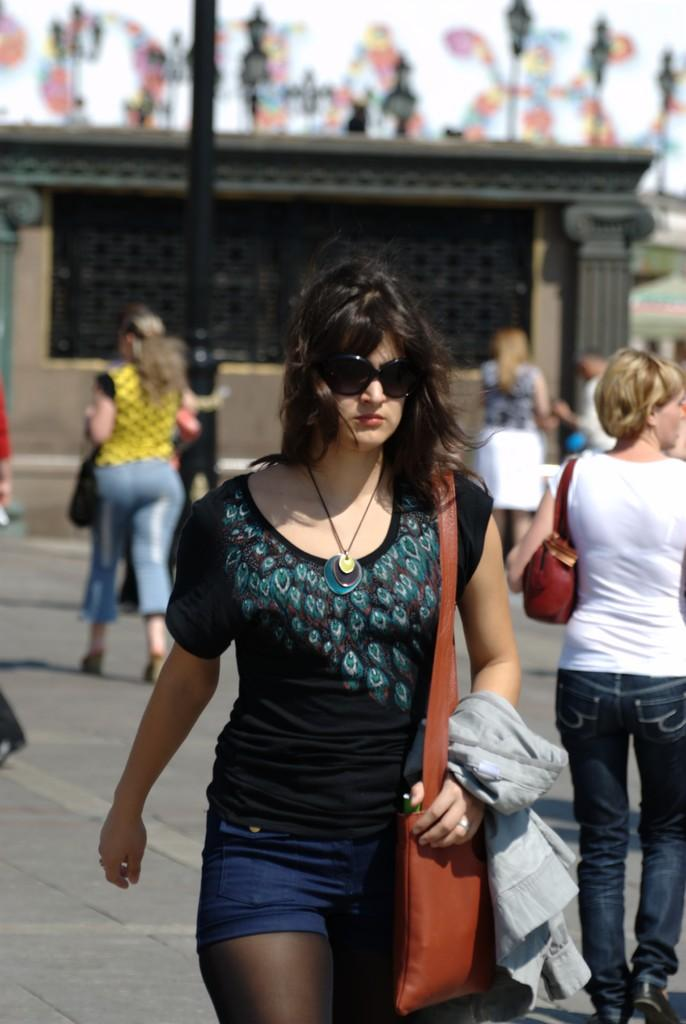How many people are in the image? There are people in the image, but the exact number is not specified. What are some people doing in the image? Some people are holding objects in the image. What can be seen beneath the people in the image? The ground is visible in the image. What type of structures can be seen in the image? There are house poles in the image. What is the quality of the background in the image? The background of the image is blurred. What language are the people speaking in the image? The facts provided do not mention any spoken language, so it is not possible to determine the language being spoken in the image. 